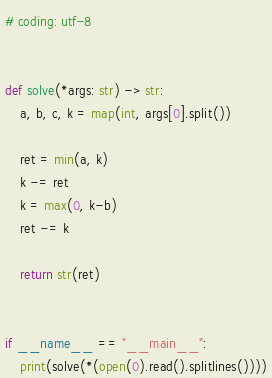<code> <loc_0><loc_0><loc_500><loc_500><_Python_># coding: utf-8


def solve(*args: str) -> str:
    a, b, c, k = map(int, args[0].split())

    ret = min(a, k)
    k -= ret
    k = max(0, k-b)
    ret -= k

    return str(ret)


if __name__ == "__main__":
    print(solve(*(open(0).read().splitlines())))
</code> 